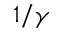<formula> <loc_0><loc_0><loc_500><loc_500>1 / \gamma</formula> 